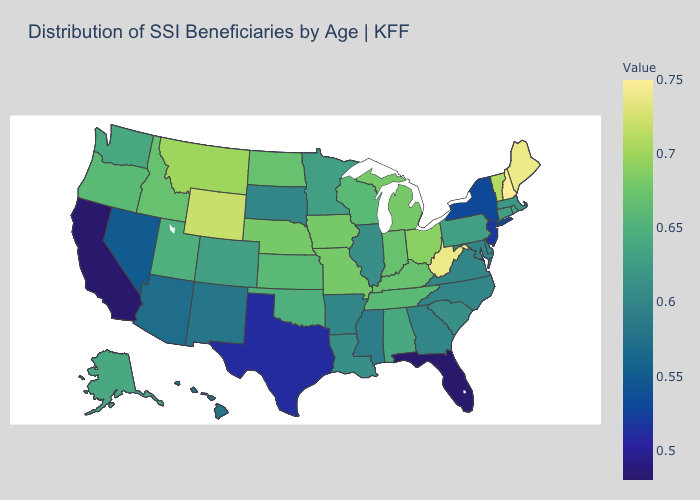Does the map have missing data?
Be succinct. No. Which states have the lowest value in the MidWest?
Write a very short answer. South Dakota. Does Washington have the highest value in the West?
Be succinct. No. Among the states that border Vermont , which have the lowest value?
Concise answer only. New York. Among the states that border Louisiana , does Mississippi have the highest value?
Give a very brief answer. No. Does Wisconsin have the lowest value in the MidWest?
Short answer required. No. 